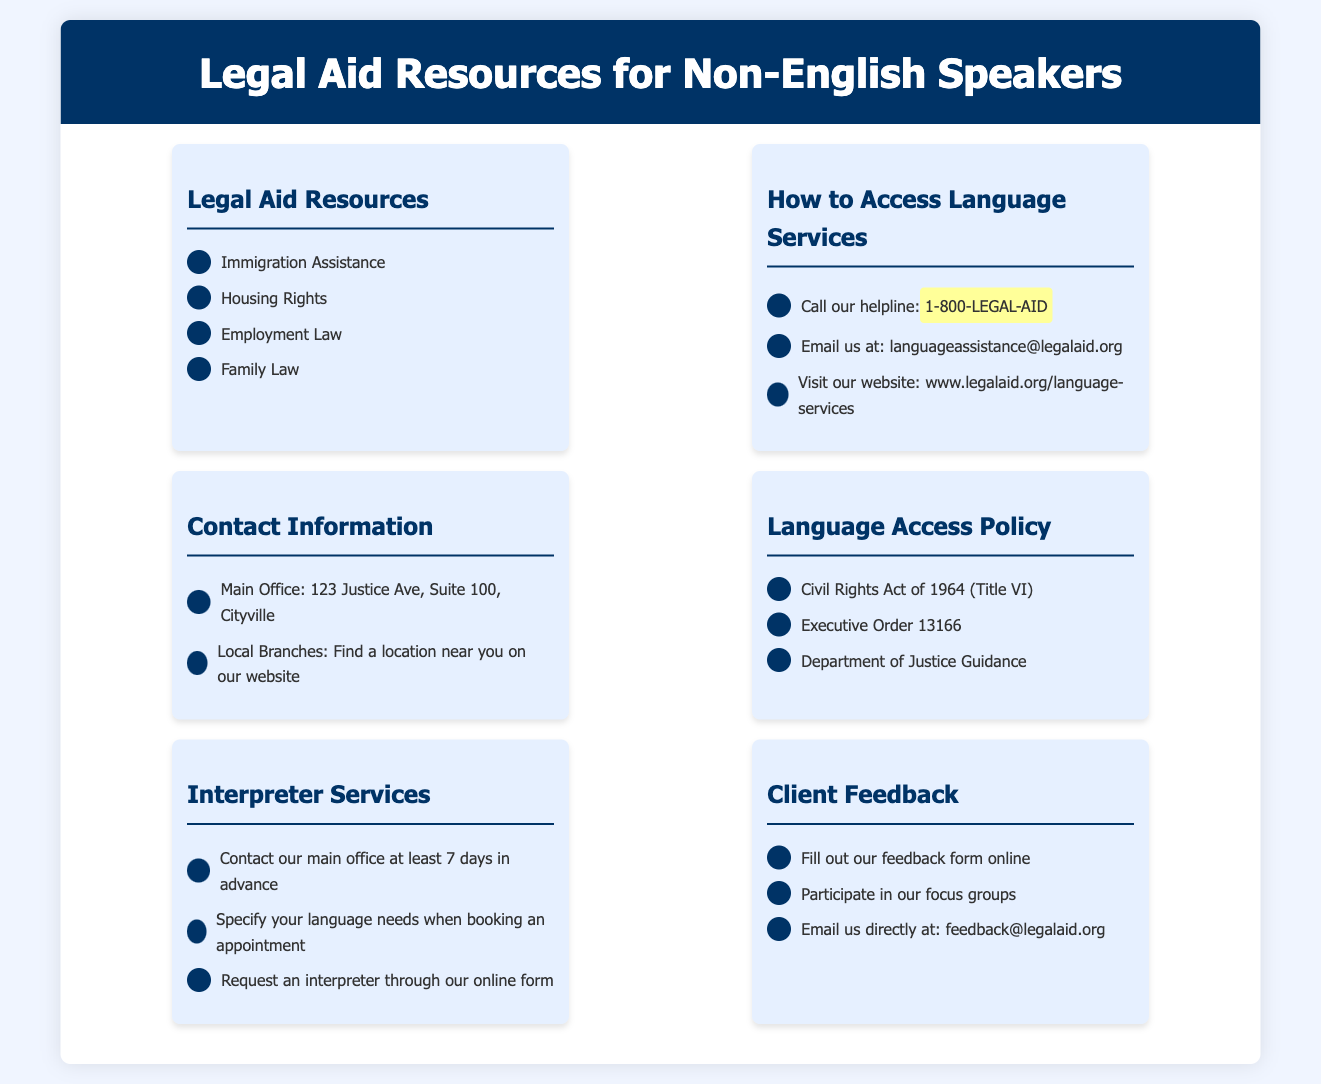what is the helpline number for legal aid? The helpline number is a key piece of contact information provided for accessing language services.
Answer: 1-800-LEGAL-AID how many types of legal aid resources are listed? The number of types of legal aid resources can be counted from the section detailing them.
Answer: 4 what service should you request at least 7 days in advance? This requires an understanding of the specific services mentioned in relation to time requirements.
Answer: Interpreter what act is mentioned in connection with the Language Access Policy? This question relates to the specific legal acts referenced in the flyer as part of the language access guidelines.
Answer: Civil Rights Act of 1964 how can clients provide feedback? This encompasses the methods outlined for clients to share their feedback about language services.
Answer: Feedback form how many sections are there in the flyer? This question involves counting the distinct sections outlined for different resources in the document.
Answer: 6 what contact method is provided for feedback? This looks for specific contact options available for clients to share their opinions.
Answer: feedback@legalaid.org what does EMO stand for in relation to language access services? This requires understanding a specific acronym possibly linked to legal frameworks or practices.
Answer: Not applicable what is the address of the main office? The address offers essential information for clients needing to visit the office directly.
Answer: 123 Justice Ave, Suite 100, Cityville 